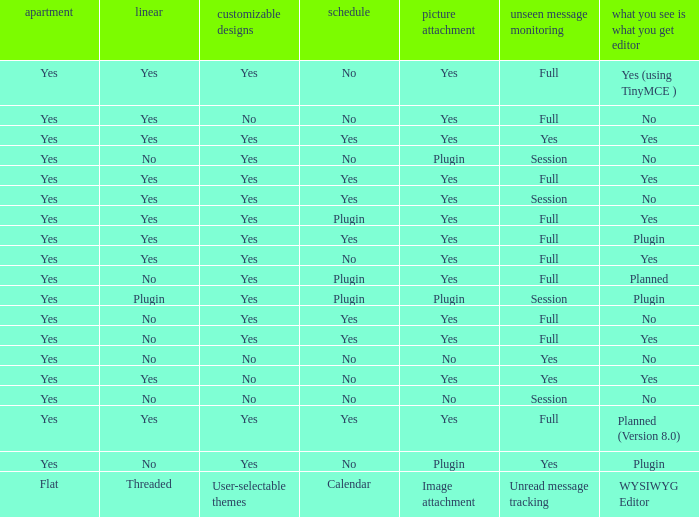Which Calendar has WYSIWYG Editor of yes and an Unread message tracking of yes? Yes, No. 